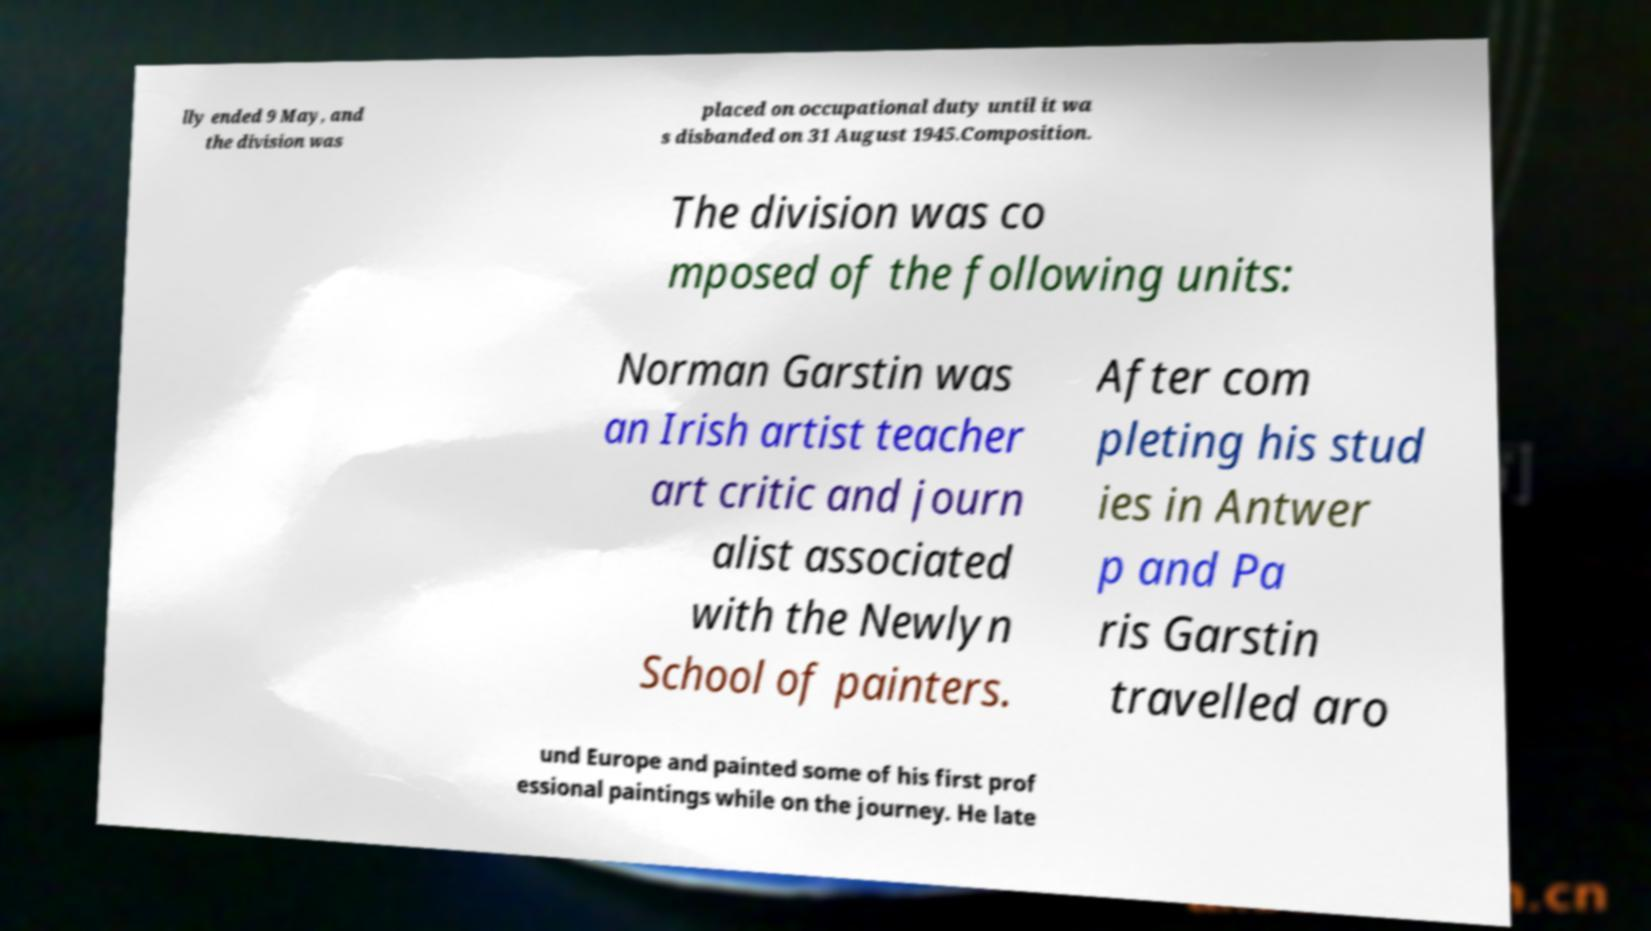For documentation purposes, I need the text within this image transcribed. Could you provide that? lly ended 9 May, and the division was placed on occupational duty until it wa s disbanded on 31 August 1945.Composition. The division was co mposed of the following units: Norman Garstin was an Irish artist teacher art critic and journ alist associated with the Newlyn School of painters. After com pleting his stud ies in Antwer p and Pa ris Garstin travelled aro und Europe and painted some of his first prof essional paintings while on the journey. He late 